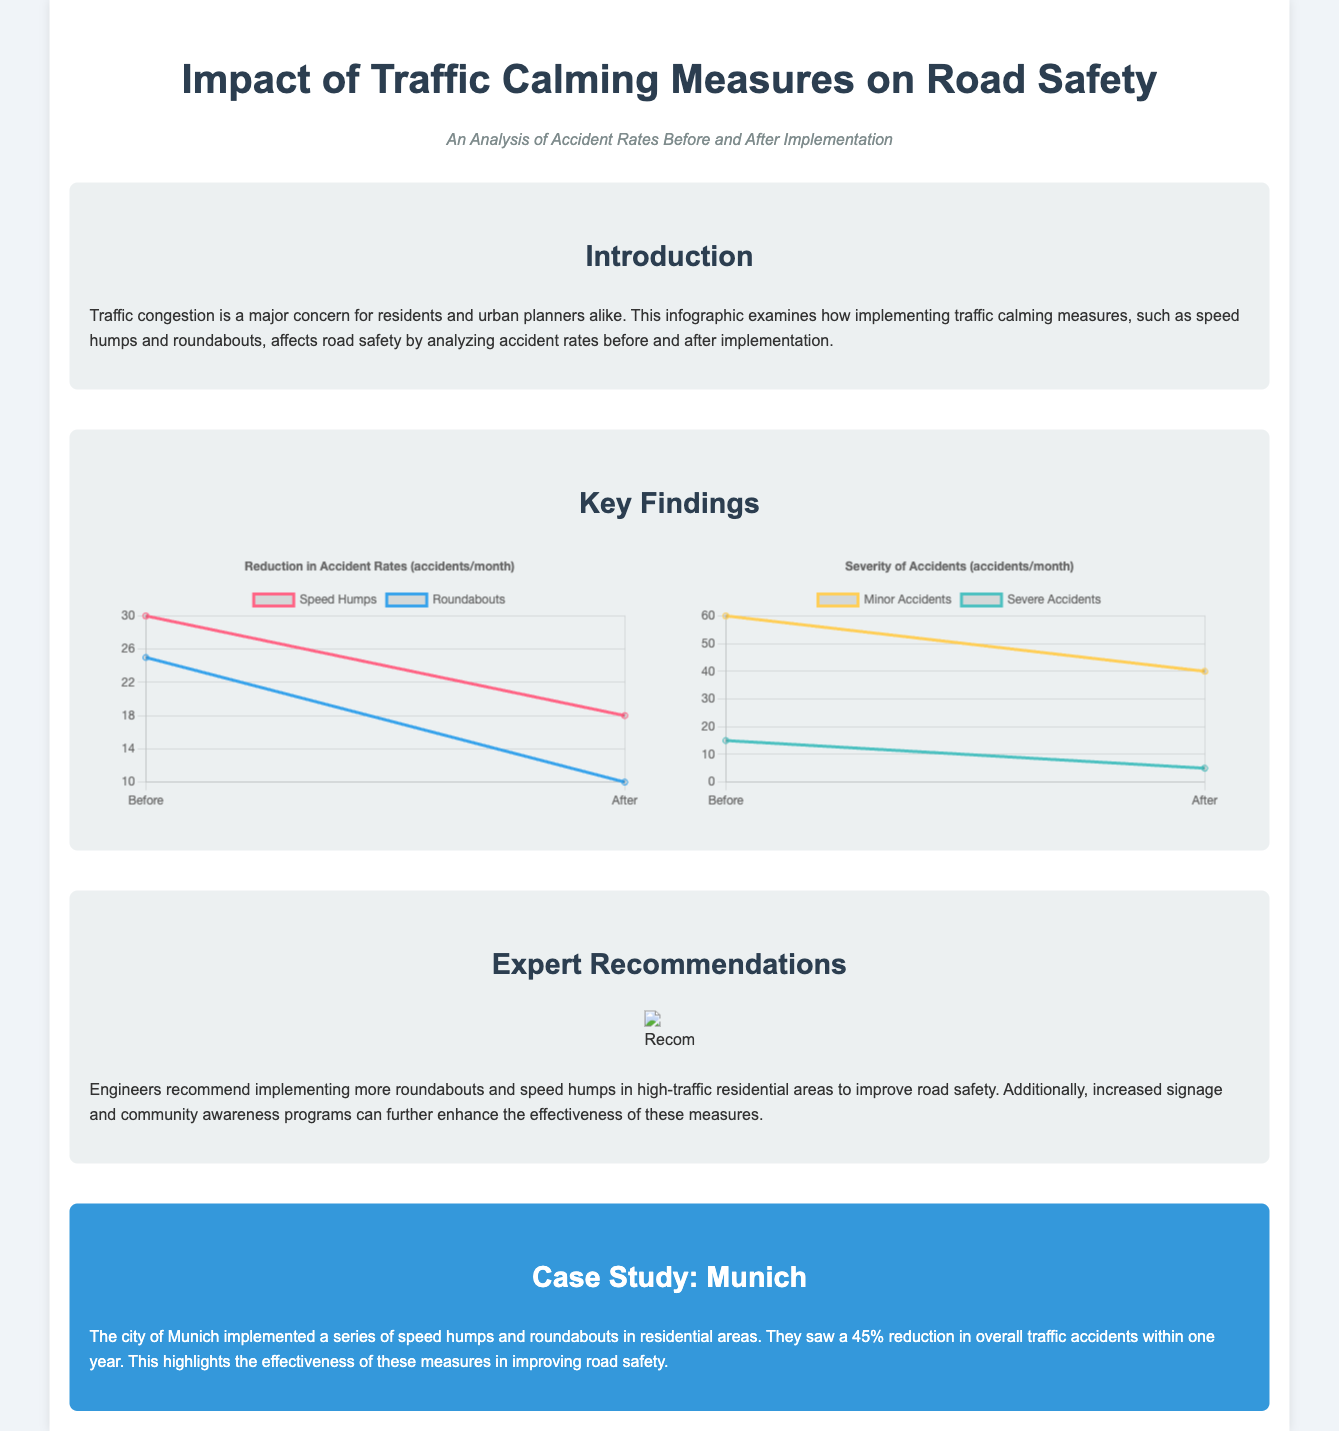What is the title of the infographic? The title of the infographic is stated at the top of the document.
Answer: Impact of Traffic Calming Measures on Road Safety What percentage reduction in overall traffic accidents did Munich see? The case study mentions a specific percentage reduction achieved in Munich after implementing traffic calming measures.
Answer: 45% How many minor accidents were reported before implementation? The accident severity chart provides the number of minor accidents reported before the implementation of traffic calming measures.
Answer: 60 Which measure resulted in a higher reduction in accidents, speed humps or roundabouts? The accident rates chart compares the reduction in accidents for both measures before and after implementation.
Answer: Roundabouts What two types of accidents are compared in the severity chart? The severity chart specifies the types of accidents that are compared regarding their frequency before and after implementation.
Answer: Minor and Severe Accidents What is the recommendation regarding signage? The expert recommendations section mentions a suggestion related to signage that enhances the effectiveness of traffic calming measures.
Answer: Increased signage What visual representation is used to show accident rates? The document uses specific types of visual data representation to display the accident rates before and after the implementation of traffic calming measures.
Answer: Line charts 